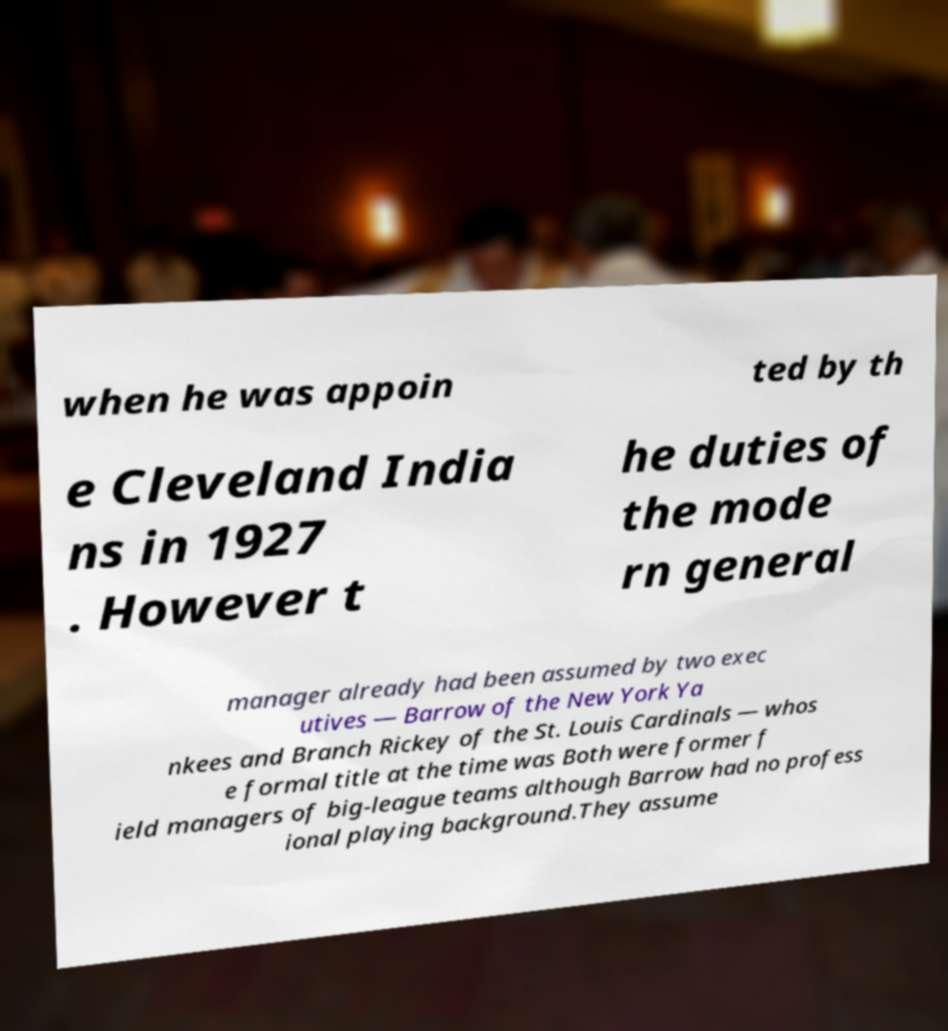Please read and relay the text visible in this image. What does it say? when he was appoin ted by th e Cleveland India ns in 1927 . However t he duties of the mode rn general manager already had been assumed by two exec utives — Barrow of the New York Ya nkees and Branch Rickey of the St. Louis Cardinals — whos e formal title at the time was Both were former f ield managers of big-league teams although Barrow had no profess ional playing background.They assume 